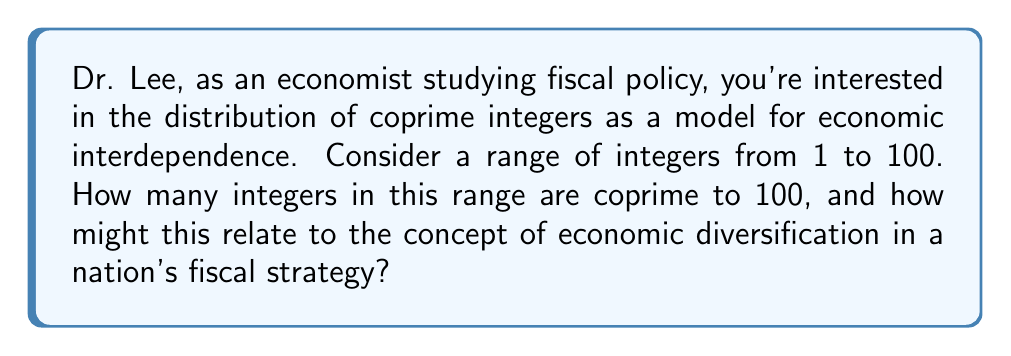Teach me how to tackle this problem. To solve this problem, we need to follow these steps:

1) First, let's factor 100:
   $100 = 2^2 \times 5^2$

2) An integer is coprime to 100 if it's not divisible by 2 or 5.

3) To count the numbers not coprime to 100, we can use the principle of inclusion-exclusion:
   
   Numbers divisible by 2: $\lfloor \frac{100}{2} \rfloor = 50$
   Numbers divisible by 5: $\lfloor \frac{100}{5} \rfloor = 20$
   Numbers divisible by both 2 and 5: $\lfloor \frac{100}{10} \rfloor = 10$

4) Therefore, the count of numbers not coprime to 100 is:
   $50 + 20 - 10 = 60$

5) The count of numbers coprime to 100 is thus:
   $100 - 60 = 40$

Economic Implication:
In economic terms, this problem can be analogous to economic diversification. The coprime numbers represent economic sectors or strategies that are "independent" from the main factors (in this case, 2 and 5, which could represent dominant economic forces).

The fact that 40% of the numbers are coprime to 100 suggests a significant level of "diversification" or "independence" within the system. In fiscal policy, this could be interpreted as a measure of economic resilience. A higher percentage of coprime numbers (or independent economic sectors) might indicate a more diversified and potentially more stable economy, better able to withstand shocks to major economic factors.

This mathematical model could be extended to analyze the interdependence and diversification in real economic systems, potentially informing strategies for robust fiscal policies.
Answer: There are 40 integers coprime to 100 in the range 1 to 100. 